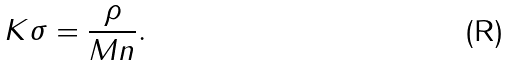Convert formula to latex. <formula><loc_0><loc_0><loc_500><loc_500>K \sigma = \frac { \rho } { M n } .</formula> 